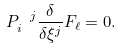<formula> <loc_0><loc_0><loc_500><loc_500>P ^ { \ j } _ { i } \frac { \delta } { \delta \xi ^ { j } } F _ { \ell } = 0 .</formula> 